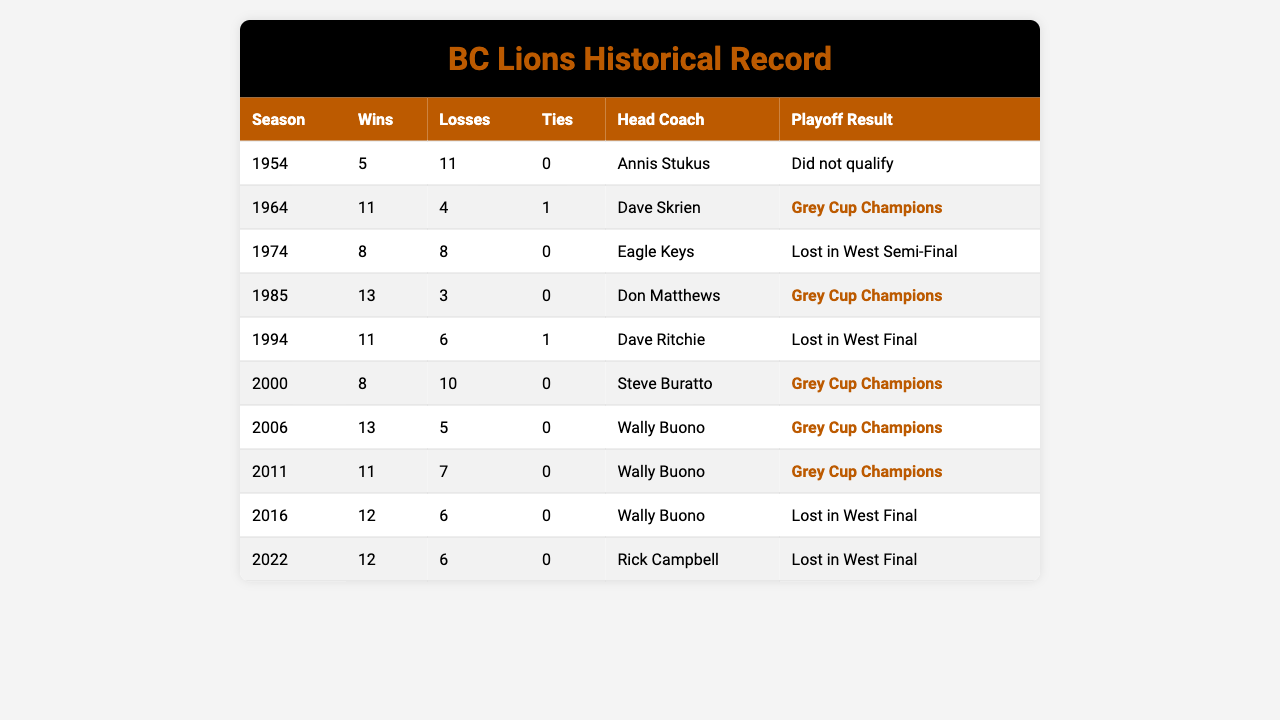What was the BC Lions' win-loss record in 1985? The table shows that in the 1985 season, the BC Lions had 13 wins and 3 losses. Therefore, their record was 13-3.
Answer: 13-3 Which season had the most wins for the BC Lions? The 1985 season had the highest number of wins with 13.
Answer: 1985 How many seasons did the BC Lions finish with a winning record? The seasons with winning records are 1964 (11-4-1), 1985 (13-3-0), 1994 (11-6-1), 2000 (8-10-0), 2006 (13-5-0), 2011 (11-7-0), 2016 (12-6-0), and 2022 (12-6-0). This totals to 8 seasons.
Answer: 8 What was the average number of wins for the BC Lions across all seasons listed? To find the average, sum the number of wins: 5 + 11 + 8 + 13 + 11 + 8 + 13 + 11 + 12 + 12 = 99. There are 10 seasons, so the average is 99/10 = 9.9.
Answer: 9.9 Did the BC Lions qualify for the playoffs in the 1954 season? The table specifies that the BC Lions did not qualify for the playoffs in 1954.
Answer: No What is the difference in the number of wins between the best and worst seasons for the BC Lions? The best season for wins is 1985 with 13 wins, and the worst season is 1954 with 5 wins. The difference is 13 - 5 = 8.
Answer: 8 How many seasons did the head coach Wally Buono lead the BC Lions, and what were the playoff results during those seasons? Wally Buono was the head coach for 4 seasons: 2006 (Grey Cup Champions), 2011 (Grey Cup Champions), and 2016 (Lost in West Final). So, he led them to 2 titles and 1 loss.
Answer: 4 seasons, 2 titles, 1 loss In what seasons did the BC Lions win the Grey Cup? The BC Lions won the Grey Cup in the seasons 1964, 1985, 2000, 2006, and 2011, totaling 5 championships.
Answer: 5 seasons Which head coach had the most playoff success with the BC Lions? Wally Buono had the most playoff success with 2 Grey Cup championships in 2006 and 2011.
Answer: Wally Buono Was there ever a season where the BC Lions had a tie in their record? Yes, the BC Lions had a tie in the 1964 season, where their record was 11 wins, 4 losses, and 1 tie.
Answer: Yes 